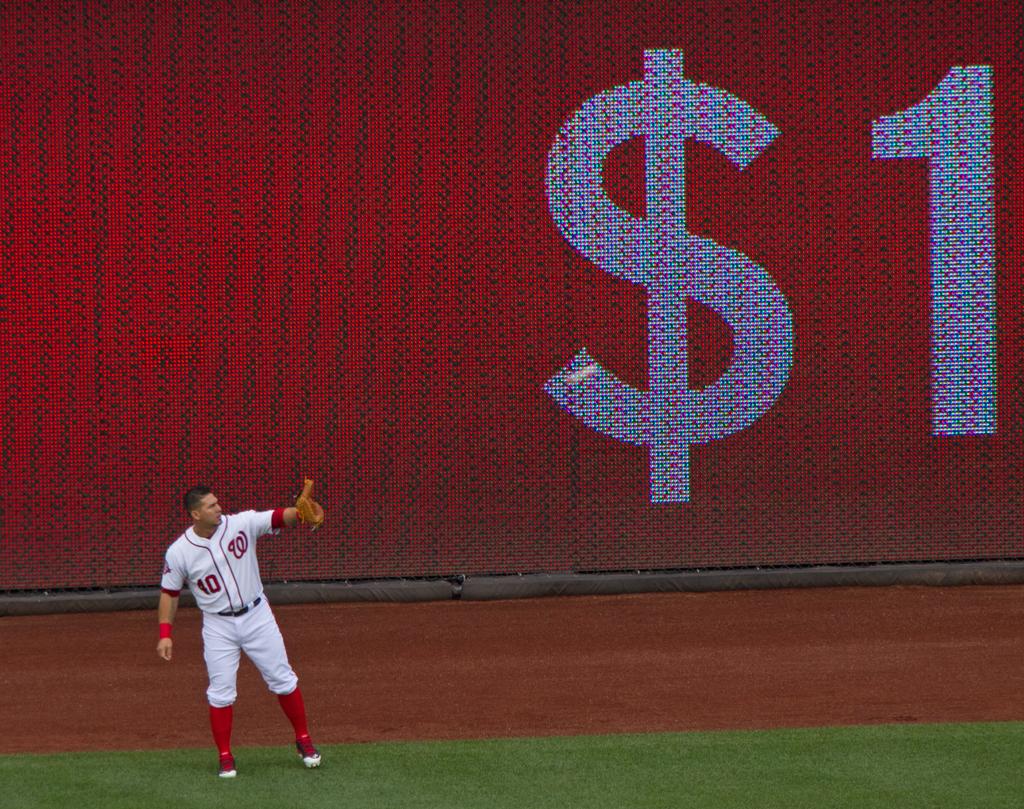What is the players jersey number?
Offer a terse response. 10. 